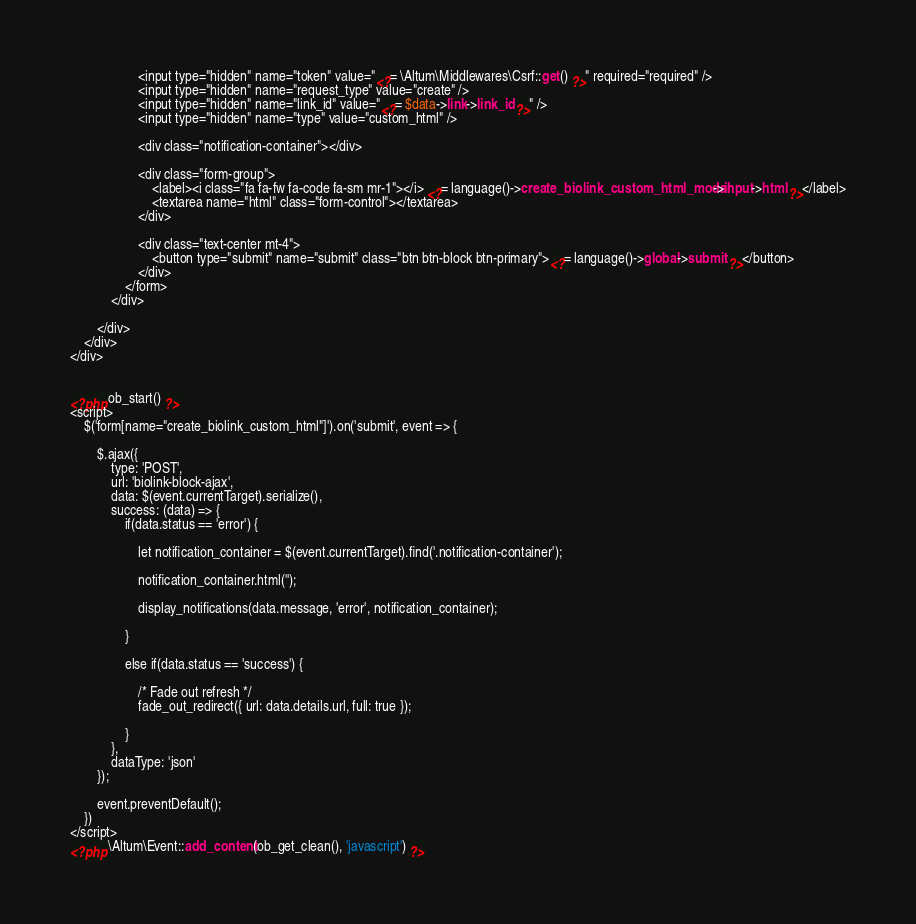Convert code to text. <code><loc_0><loc_0><loc_500><loc_500><_PHP_>                    <input type="hidden" name="token" value="<?= \Altum\Middlewares\Csrf::get() ?>" required="required" />
                    <input type="hidden" name="request_type" value="create" />
                    <input type="hidden" name="link_id" value="<?= $data->link->link_id ?>" />
                    <input type="hidden" name="type" value="custom_html" />

                    <div class="notification-container"></div>

                    <div class="form-group">
                        <label><i class="fa fa-fw fa-code fa-sm mr-1"></i> <?= language()->create_biolink_custom_html_modal->input->html ?></label>
                        <textarea name="html" class="form-control"></textarea>
                    </div>

                    <div class="text-center mt-4">
                        <button type="submit" name="submit" class="btn btn-block btn-primary"><?= language()->global->submit ?></button>
                    </div>
                </form>
            </div>

        </div>
    </div>
</div>


<?php ob_start() ?>
<script>
    $('form[name="create_biolink_custom_html"]').on('submit', event => {

        $.ajax({
            type: 'POST',
            url: 'biolink-block-ajax',
            data: $(event.currentTarget).serialize(),
            success: (data) => {
                if(data.status == 'error') {

                    let notification_container = $(event.currentTarget).find('.notification-container');

                    notification_container.html('');

                    display_notifications(data.message, 'error', notification_container);

                }

                else if(data.status == 'success') {

                    /* Fade out refresh */
                    fade_out_redirect({ url: data.details.url, full: true });

                }
            },
            dataType: 'json'
        });

        event.preventDefault();
    })
</script>
<?php \Altum\Event::add_content(ob_get_clean(), 'javascript') ?>
</code> 